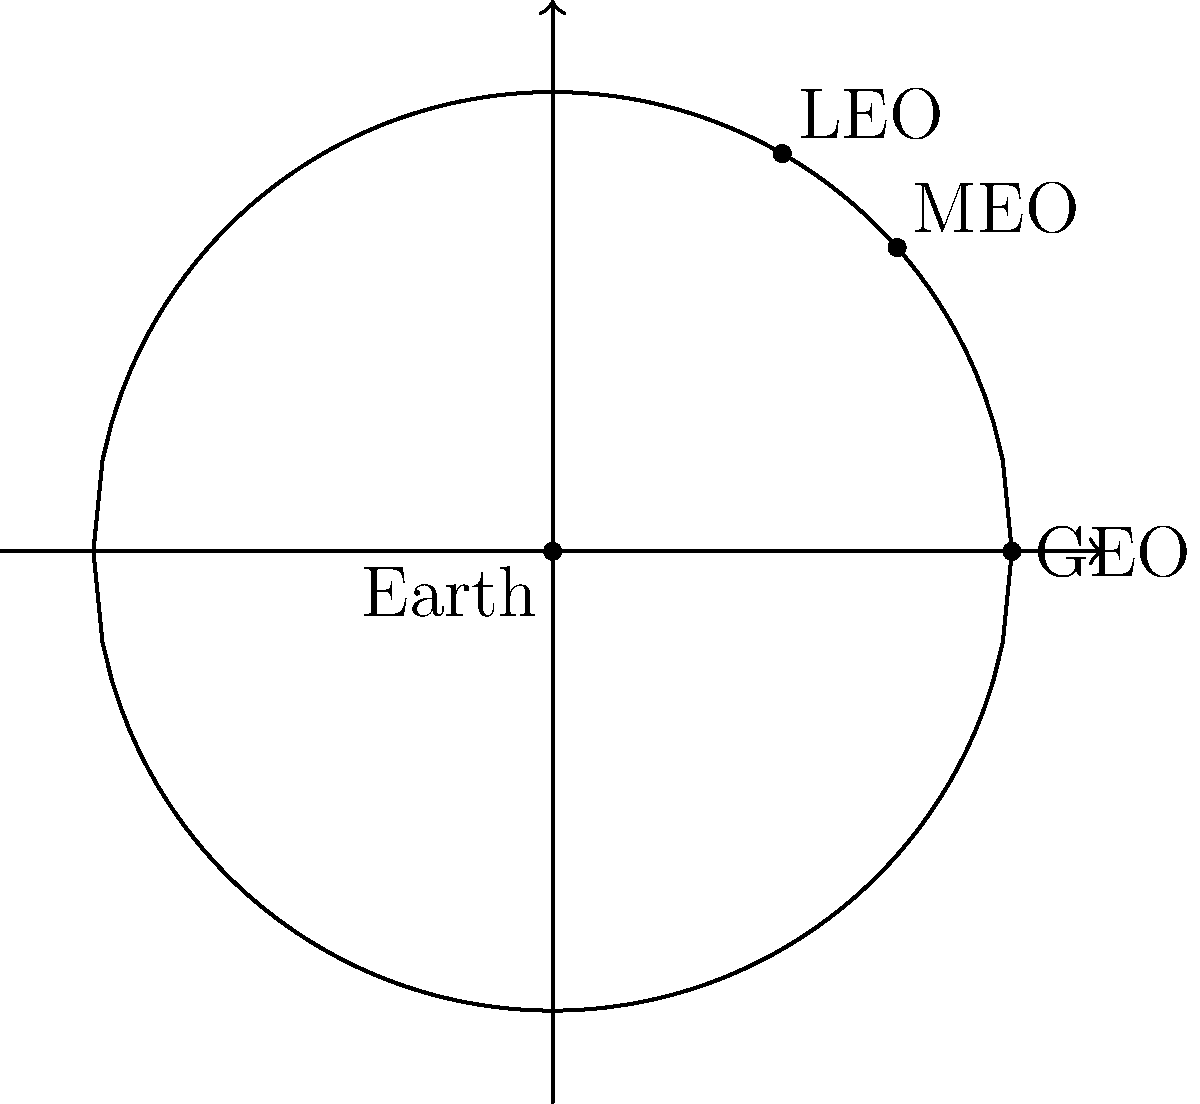In your coverage of international space cooperation, you've learned about different satellite orbits. Based on the simplified graphic representation of satellite orbits around Earth, which orbit would be most suitable for a joint Indo-Pakistani satellite designed to provide continuous communication coverage over the subcontinent? To answer this question, let's consider the characteristics of each orbit shown in the graphic:

1. LEO (Low Earth Orbit):
   - Closest to Earth
   - Satellites move quickly relative to Earth's surface
   - Limited coverage area, requiring multiple satellites for continuous coverage

2. MEO (Medium Earth Orbit):
   - Between LEO and GEO
   - Provides wider coverage than LEO but still requires multiple satellites for continuous coverage
   - Commonly used for navigation systems like GPS

3. GEO (Geostationary Earth Orbit):
   - Farthest from Earth among the shown orbits
   - Satellites in this orbit appear stationary relative to Earth's surface
   - Provides continuous coverage over a large area (about 1/3 of Earth's surface)

For a joint Indo-Pakistani satellite designed to provide continuous communication coverage over the subcontinent:

- LEO would not be suitable as it would require multiple satellites to maintain continuous coverage.
- MEO could work but would still require multiple satellites and complex handovers.
- GEO is the most suitable option because:
  a) A single satellite can provide continuous coverage over the entire Indian subcontinent.
  b) It appears stationary, simplifying ground antenna positioning.
  c) It's ideal for communication satellites covering large geographical areas.

Therefore, the GEO (Geostationary Earth Orbit) would be the most suitable for this joint mission.
Answer: GEO (Geostationary Earth Orbit) 